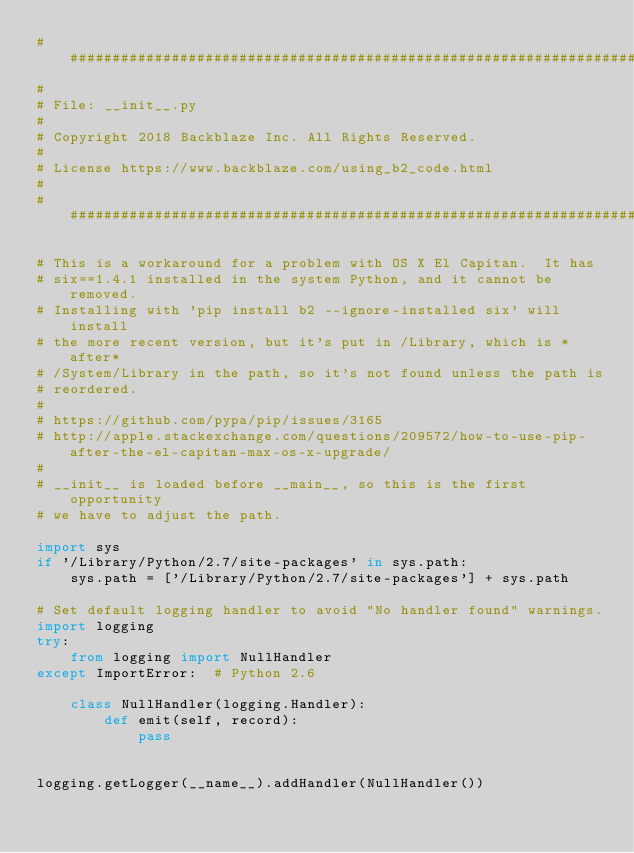Convert code to text. <code><loc_0><loc_0><loc_500><loc_500><_Python_>######################################################################
#
# File: __init__.py
#
# Copyright 2018 Backblaze Inc. All Rights Reserved.
#
# License https://www.backblaze.com/using_b2_code.html
#
######################################################################

# This is a workaround for a problem with OS X El Capitan.  It has
# six==1.4.1 installed in the system Python, and it cannot be removed.
# Installing with 'pip install b2 --ignore-installed six' will install
# the more recent version, but it's put in /Library, which is *after*
# /System/Library in the path, so it's not found unless the path is
# reordered.
#
# https://github.com/pypa/pip/issues/3165
# http://apple.stackexchange.com/questions/209572/how-to-use-pip-after-the-el-capitan-max-os-x-upgrade/
#
# __init__ is loaded before __main__, so this is the first opportunity
# we have to adjust the path.

import sys
if '/Library/Python/2.7/site-packages' in sys.path:
    sys.path = ['/Library/Python/2.7/site-packages'] + sys.path

# Set default logging handler to avoid "No handler found" warnings.
import logging
try:
    from logging import NullHandler
except ImportError:  # Python 2.6

    class NullHandler(logging.Handler):
        def emit(self, record):
            pass


logging.getLogger(__name__).addHandler(NullHandler())
</code> 